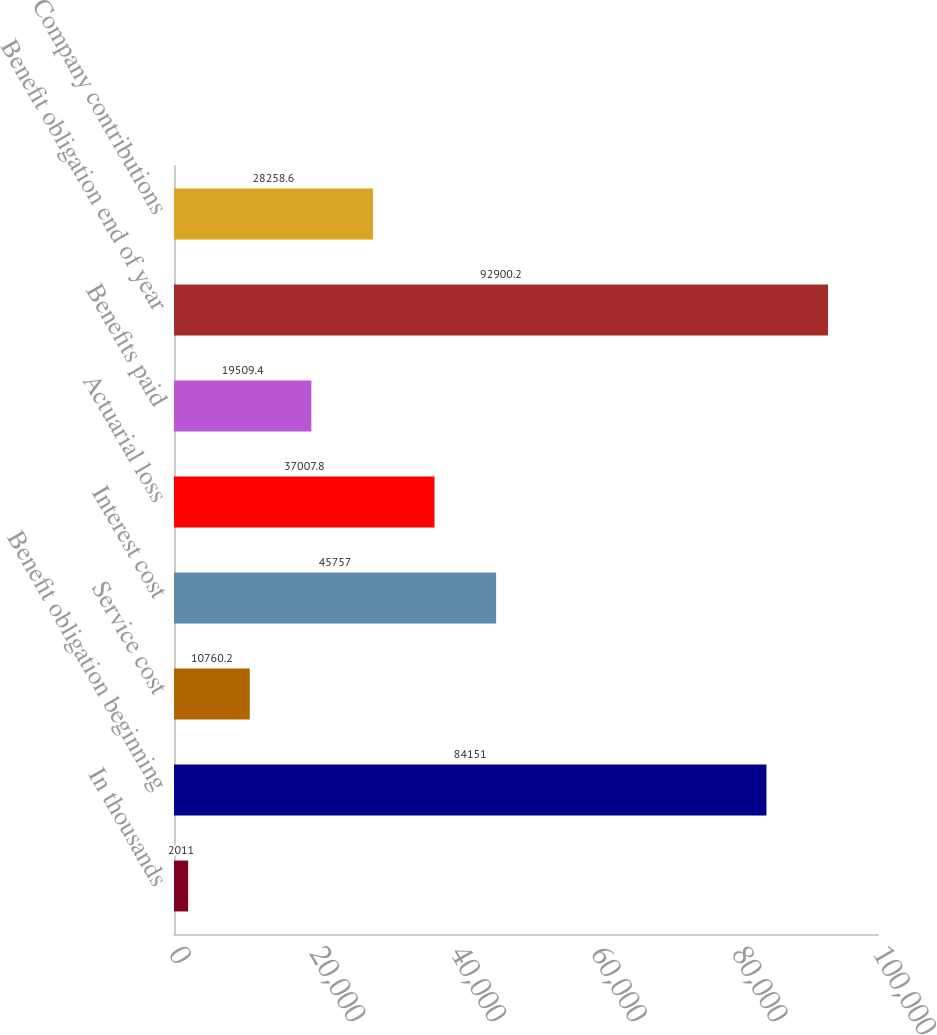Convert chart. <chart><loc_0><loc_0><loc_500><loc_500><bar_chart><fcel>In thousands<fcel>Benefit obligation beginning<fcel>Service cost<fcel>Interest cost<fcel>Actuarial loss<fcel>Benefits paid<fcel>Benefit obligation end of year<fcel>Company contributions<nl><fcel>2011<fcel>84151<fcel>10760.2<fcel>45757<fcel>37007.8<fcel>19509.4<fcel>92900.2<fcel>28258.6<nl></chart> 